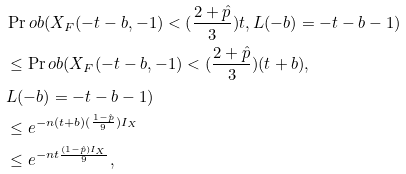<formula> <loc_0><loc_0><loc_500><loc_500>& \Pr o b ( X _ { F } ( - t - b , - 1 ) < ( \frac { 2 + \hat { p } } { 3 } ) t , L ( - b ) = - t - b - 1 ) \\ & \leq \Pr o b ( X _ { F } ( - t - b , - 1 ) < ( \frac { 2 + \hat { p } } { 3 } ) ( t + b ) , \\ & L ( - b ) = - t - b - 1 ) \\ & \leq e ^ { - n ( t + b ) ( \frac { 1 - \hat { p } } { 9 } ) I _ { X } } \\ & \leq e ^ { - n t \frac { ( 1 - \hat { p } ) I _ { X } } { 9 } } ,</formula> 